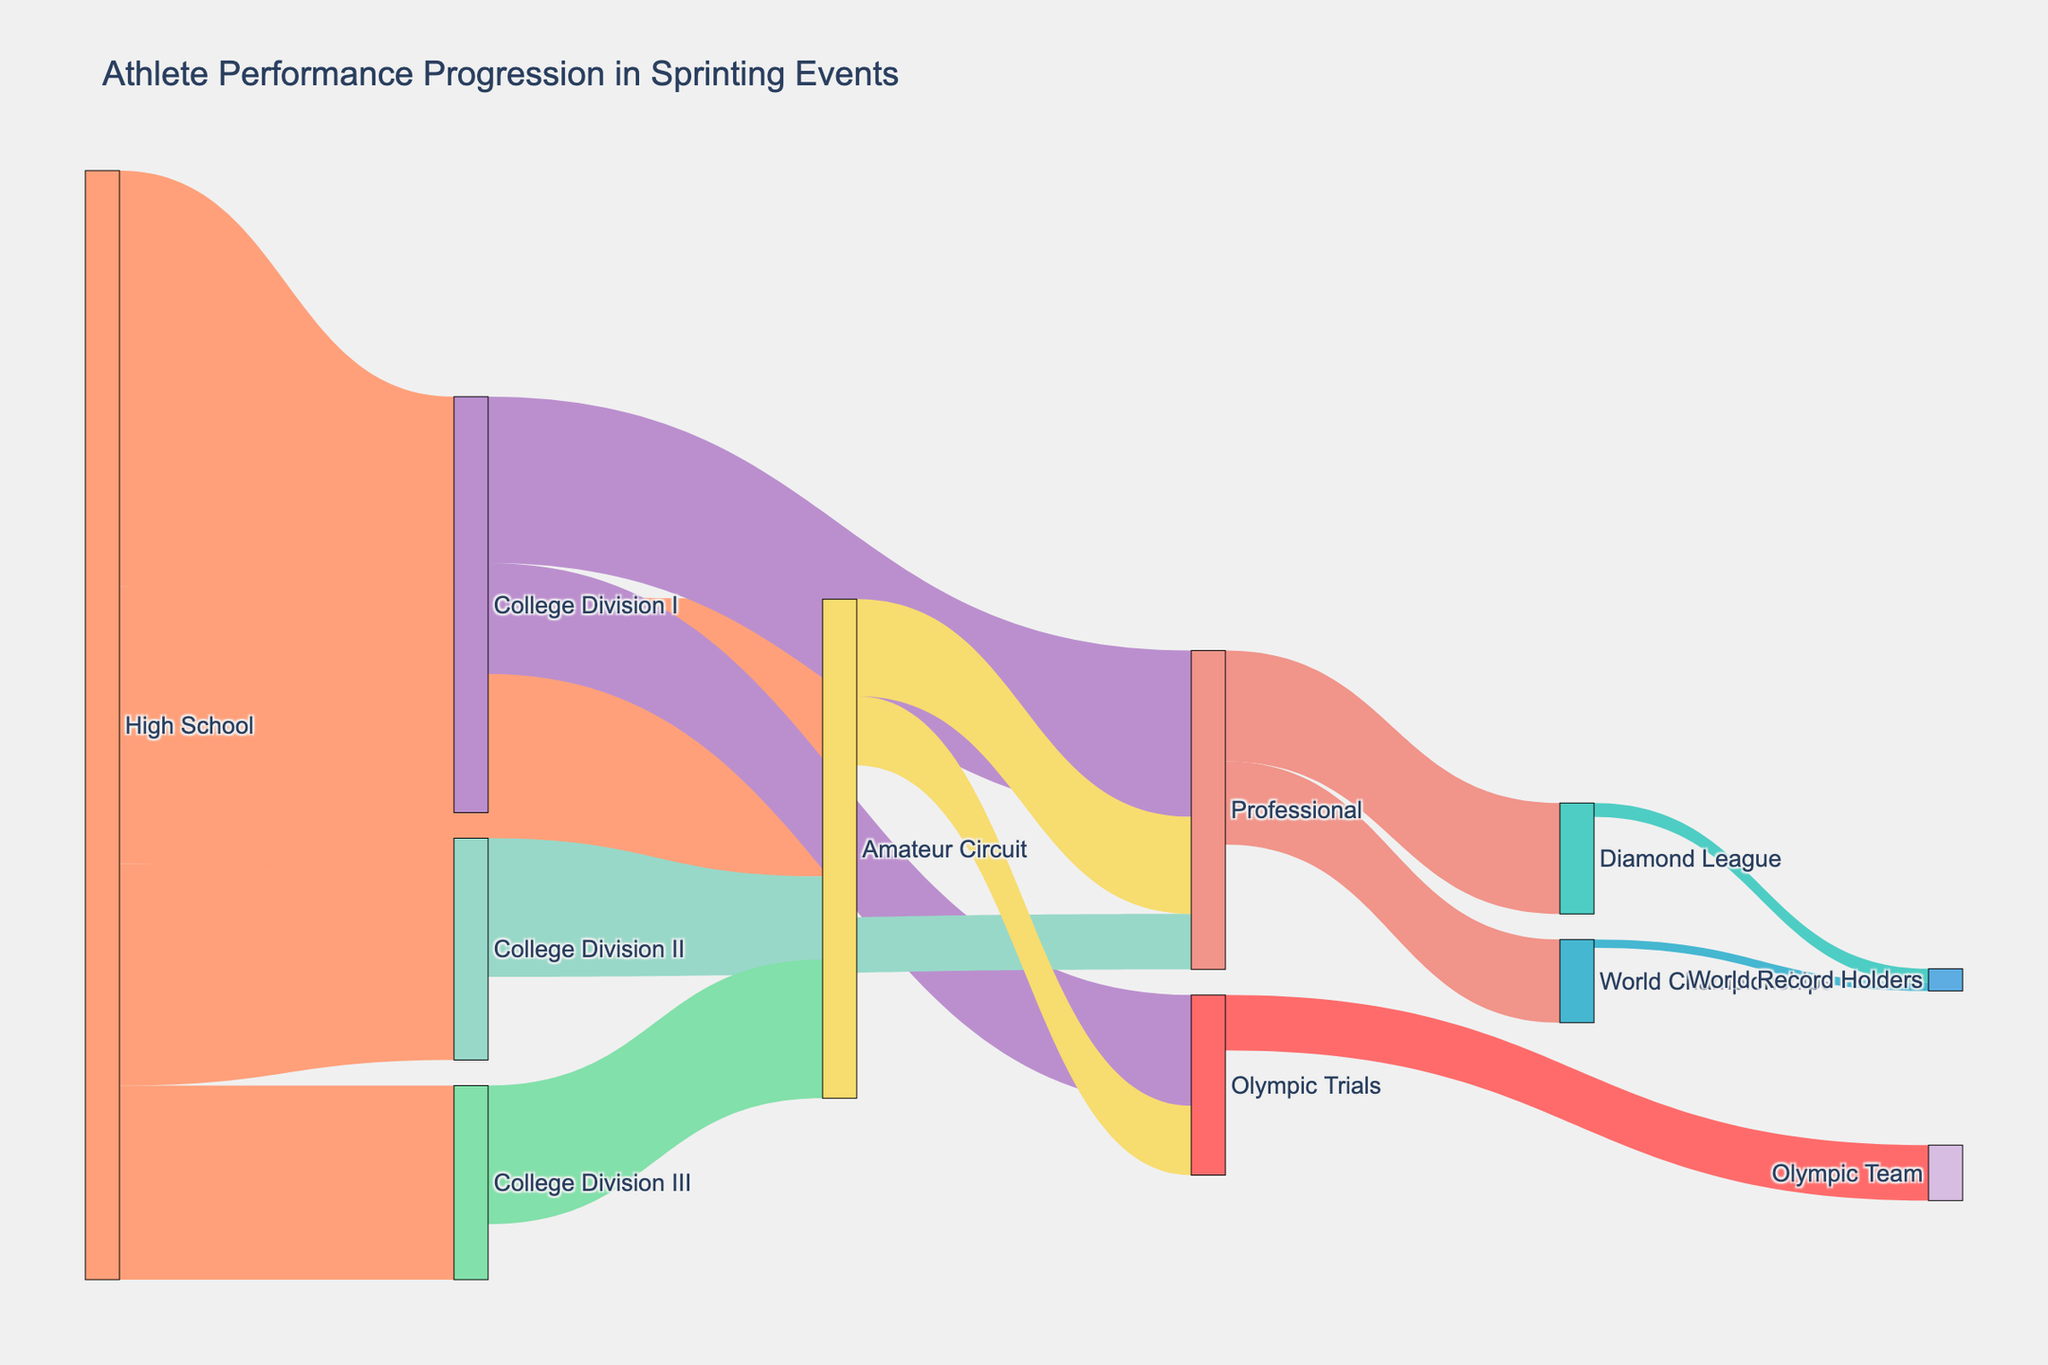What is the title of the figure? The title is usually displayed at the top of the figure. It provides a brief description of what the figure represents.
Answer: Athlete Performance Progression in Sprinting Events Which level has the highest number of transitions originating from it? To find this, count the transitions going out from each level. The level with the most outgoing values is the correct answer.
Answer: High School How many athletes transitioned from College Division I to the Professional level? Look for the connection between "College Division I" and "Professional" and check its value.
Answer: 60 What is the total number of athletes that entered the Amateur Circuit after High School? Sum the values of transitions from High School to the Amateur Circuit.
Answer: 100 Which has more transitions, College Division I to Olympic Trials or College Division II to Professional? Compare the values between "College Division I to Olympic Trials" and "College Division II to Professional".
Answer: College Division I to Olympic Trials What is the total transition count for athletes moving to Professional from all sources? Add the values of all transitions that end at the Professional node.
Answer: 115 (60 from College Division I + 20 from College Division II + 35 from Amateur Circuit) How many athletes advanced into the World Record Holders category? Sum the values of all transitions that end at the World Record Holders node.
Answer: 8 (5 from Diamond League + 3 from World Championships) Which transition has a higher value, High School to College Division II or High School to College Division III? Compare the transition values from High School to College Division II and High School to College Division III.
Answer: High School to College Division II What is the combined number of athletes progressing from the Amateur Circuit to Professional and Olympic Trials? Add the transition values from the Amateur Circuit to Professional and Olympic Trials.
Answer: 60 (35 to Professional + 25 to Olympic Trials) From the College divisions, which transition has the lowest count and what is its value? Identify the smallest value among transitions originating from all College divisions.
Answer: College Division II to Professional, 20 